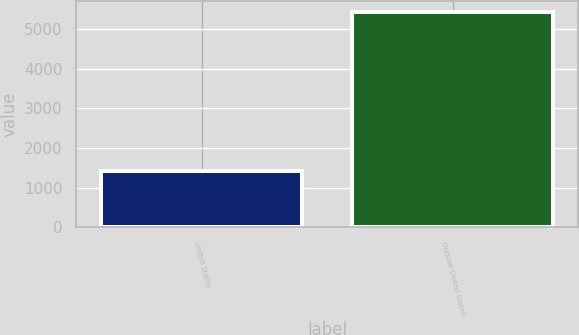<chart> <loc_0><loc_0><loc_500><loc_500><bar_chart><fcel>United States<fcel>Outside United States<nl><fcel>1432<fcel>5420<nl></chart> 